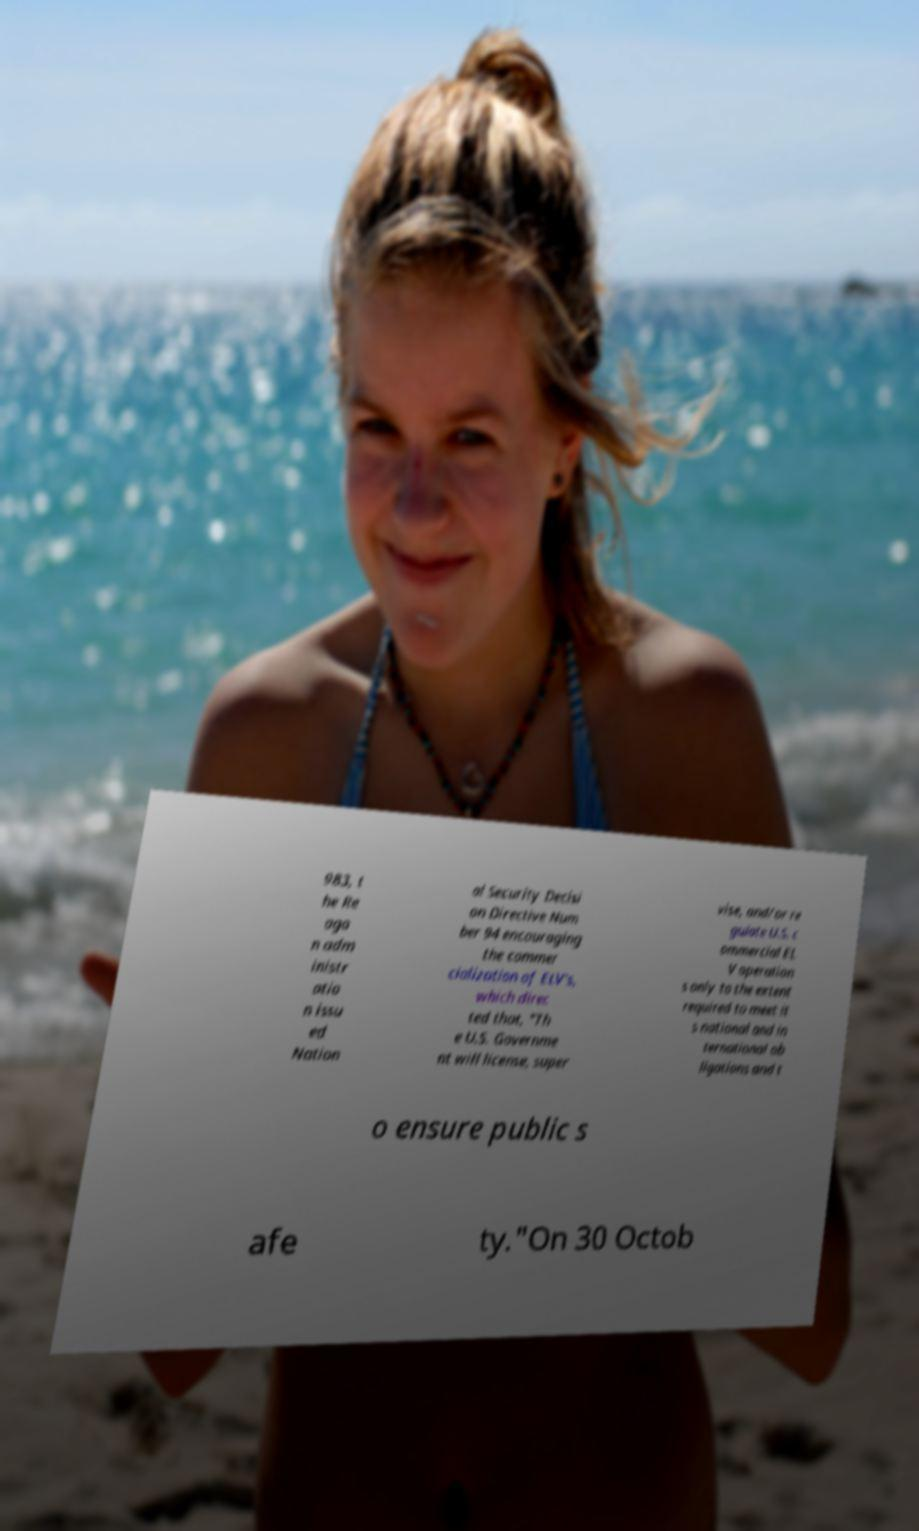What messages or text are displayed in this image? I need them in a readable, typed format. 983, t he Re aga n adm inistr atio n issu ed Nation al Security Decisi on Directive Num ber 94 encouraging the commer cialization of ELV’s, which direc ted that, "Th e U.S. Governme nt will license, super vise, and/or re gulate U.S. c ommercial EL V operation s only to the extent required to meet it s national and in ternational ob ligations and t o ensure public s afe ty."On 30 Octob 